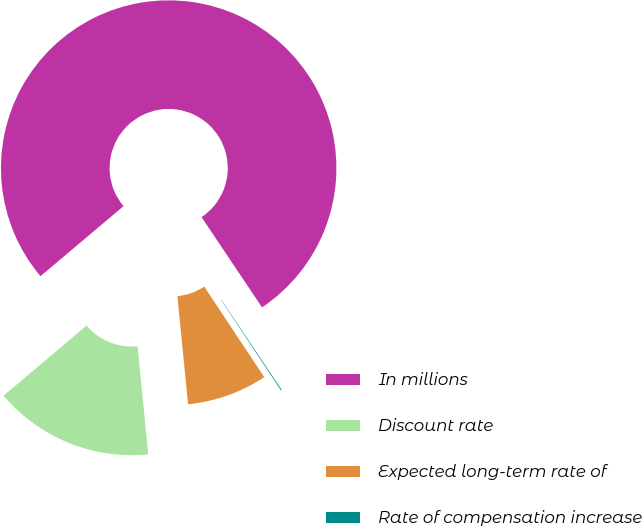Convert chart. <chart><loc_0><loc_0><loc_500><loc_500><pie_chart><fcel>In millions<fcel>Discount rate<fcel>Expected long-term rate of<fcel>Rate of compensation increase<nl><fcel>76.76%<fcel>15.41%<fcel>7.75%<fcel>0.08%<nl></chart> 